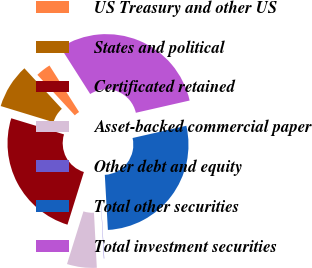<chart> <loc_0><loc_0><loc_500><loc_500><pie_chart><fcel>US Treasury and other US<fcel>States and political<fcel>Certificated retained<fcel>Asset-backed commercial paper<fcel>Other debt and equity<fcel>Total other securities<fcel>Total investment securities<nl><fcel>2.85%<fcel>8.41%<fcel>24.91%<fcel>5.63%<fcel>0.07%<fcel>27.68%<fcel>30.46%<nl></chart> 